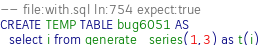<code> <loc_0><loc_0><loc_500><loc_500><_SQL_>-- file:with.sql ln:754 expect:true
CREATE TEMP TABLE bug6051 AS
  select i from generate_series(1,3) as t(i)
</code> 